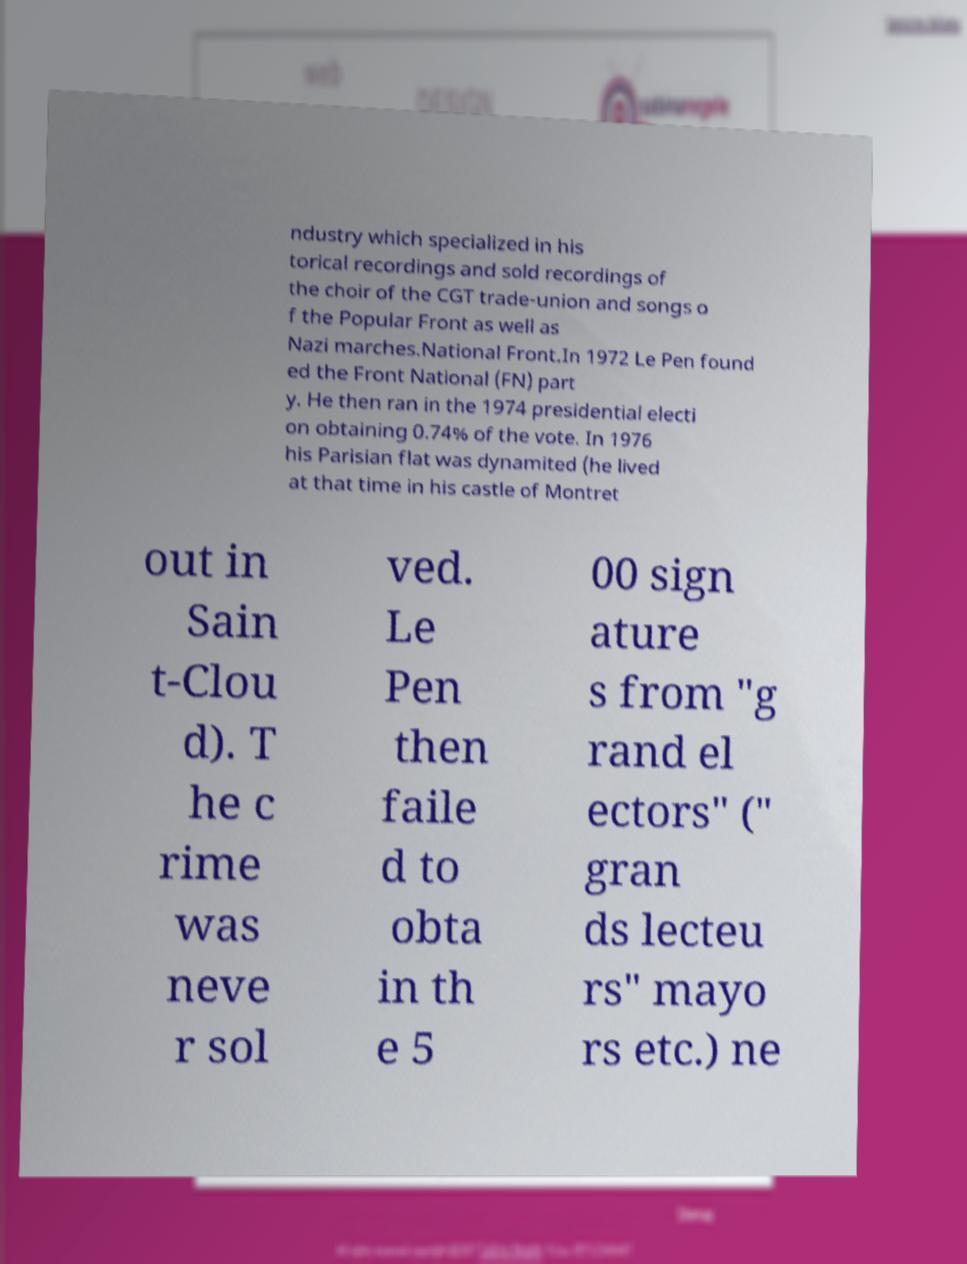Please identify and transcribe the text found in this image. ndustry which specialized in his torical recordings and sold recordings of the choir of the CGT trade-union and songs o f the Popular Front as well as Nazi marches.National Front.In 1972 Le Pen found ed the Front National (FN) part y. He then ran in the 1974 presidential electi on obtaining 0.74% of the vote. In 1976 his Parisian flat was dynamited (he lived at that time in his castle of Montret out in Sain t-Clou d). T he c rime was neve r sol ved. Le Pen then faile d to obta in th e 5 00 sign ature s from "g rand el ectors" (" gran ds lecteu rs" mayo rs etc.) ne 